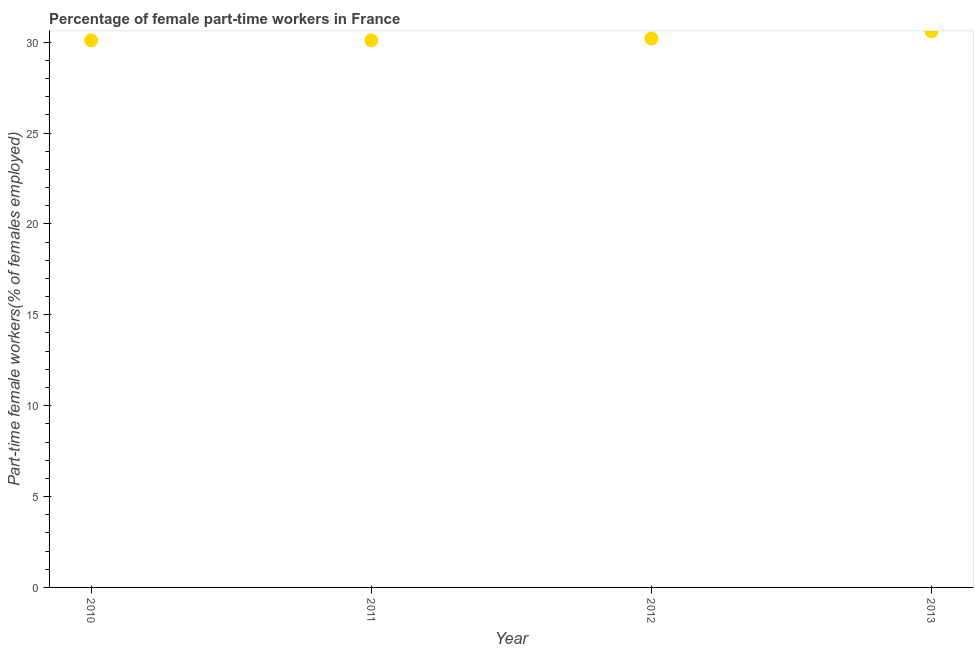What is the percentage of part-time female workers in 2013?
Provide a succinct answer. 30.6. Across all years, what is the maximum percentage of part-time female workers?
Your response must be concise. 30.6. Across all years, what is the minimum percentage of part-time female workers?
Offer a very short reply. 30.1. In which year was the percentage of part-time female workers minimum?
Ensure brevity in your answer.  2010. What is the sum of the percentage of part-time female workers?
Offer a very short reply. 121. What is the difference between the percentage of part-time female workers in 2011 and 2012?
Give a very brief answer. -0.1. What is the average percentage of part-time female workers per year?
Your answer should be compact. 30.25. What is the median percentage of part-time female workers?
Provide a short and direct response. 30.15. Do a majority of the years between 2010 and 2012 (inclusive) have percentage of part-time female workers greater than 14 %?
Offer a terse response. Yes. What is the ratio of the percentage of part-time female workers in 2010 to that in 2013?
Your answer should be compact. 0.98. What is the difference between the highest and the second highest percentage of part-time female workers?
Your answer should be very brief. 0.4. Is the sum of the percentage of part-time female workers in 2010 and 2013 greater than the maximum percentage of part-time female workers across all years?
Your response must be concise. Yes. What is the difference between the highest and the lowest percentage of part-time female workers?
Ensure brevity in your answer.  0.5. How many dotlines are there?
Offer a very short reply. 1. How many years are there in the graph?
Give a very brief answer. 4. Does the graph contain any zero values?
Keep it short and to the point. No. What is the title of the graph?
Give a very brief answer. Percentage of female part-time workers in France. What is the label or title of the Y-axis?
Provide a short and direct response. Part-time female workers(% of females employed). What is the Part-time female workers(% of females employed) in 2010?
Ensure brevity in your answer.  30.1. What is the Part-time female workers(% of females employed) in 2011?
Make the answer very short. 30.1. What is the Part-time female workers(% of females employed) in 2012?
Provide a short and direct response. 30.2. What is the Part-time female workers(% of females employed) in 2013?
Your answer should be compact. 30.6. What is the difference between the Part-time female workers(% of females employed) in 2010 and 2011?
Offer a terse response. 0. What is the difference between the Part-time female workers(% of females employed) in 2011 and 2012?
Make the answer very short. -0.1. What is the difference between the Part-time female workers(% of females employed) in 2011 and 2013?
Offer a very short reply. -0.5. What is the ratio of the Part-time female workers(% of females employed) in 2010 to that in 2011?
Give a very brief answer. 1. What is the ratio of the Part-time female workers(% of females employed) in 2010 to that in 2012?
Your answer should be compact. 1. What is the ratio of the Part-time female workers(% of females employed) in 2010 to that in 2013?
Give a very brief answer. 0.98. 